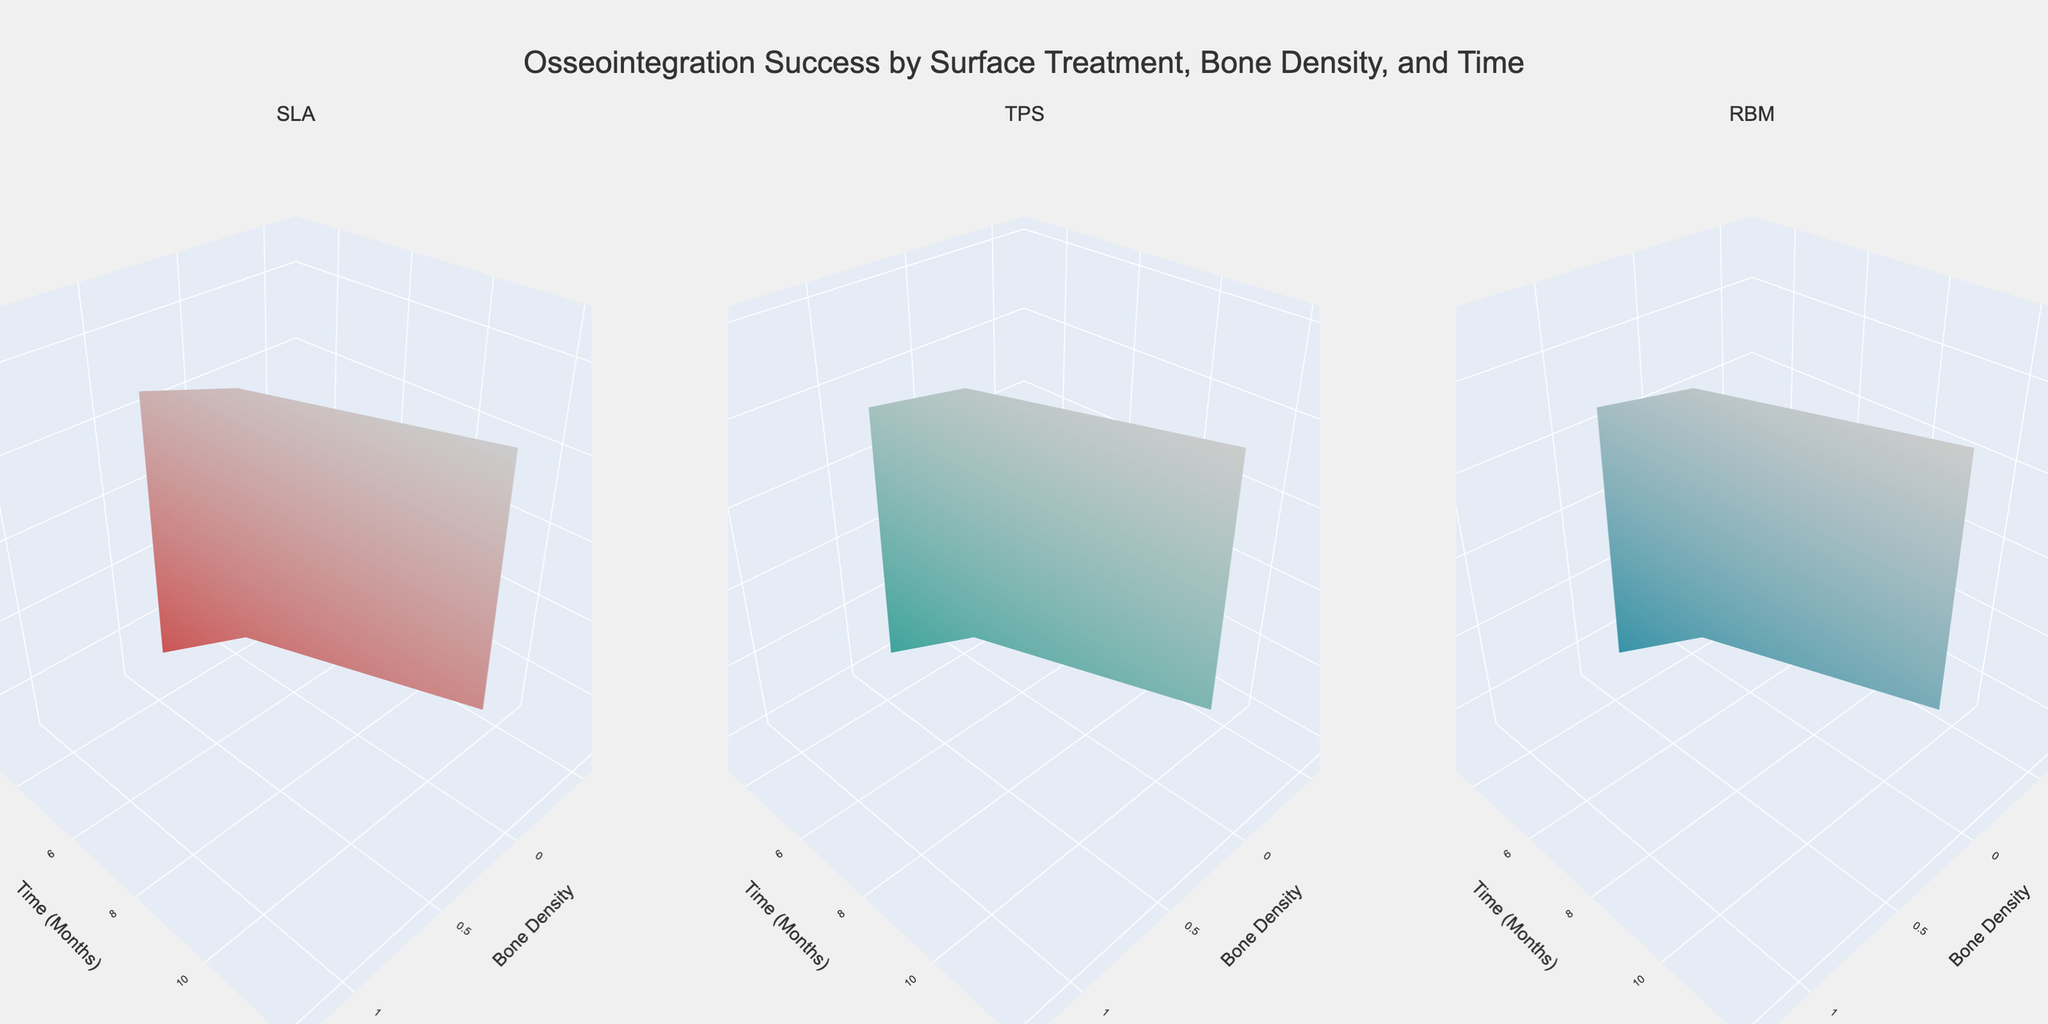What's the title of the plot? The title is centrally positioned at the top of the figure. It reads, "Osseointegration Success by Surface Treatment, Bone Density, and Time".
Answer: Osseointegration Success by Surface Treatment, Bone Density, and Time What are the three surface treatments compared in the subplots? The subplot titles along the top indicate the three surface treatments being compared: "SLA", "TPS", and "RBM".
Answer: SLA, TPS, RBM How does the osseointegration success rate change over time for SLA surface treatment with a bone density of 0.6? For SLA and bone density 0.6, the osseointegration success rates at time points 3, 6, and 12 months are shown as surfaces. At 3 months, it’s 78%, at 6 months, it's 89%, and at 12 months, it's 94%.
Answer: 78% at 3 months, 89% at 6 months, 94% at 12 months Which surface treatment shows the highest osseointegration success after 12 months for bone density of 0.9? By comparing the three subplots, all treatments reach their highest points at 12 months for bone density of 0.9. Among these, SLA has the highest value at 97%.
Answer: SLA What is the difference in osseointegration success at 6 months between bone densities 0.3 and 0.9 for TPS surface treatment? For TPS at 6 months, the osseointegration success rates for bone densities 0.3 and 0.9 can be observed. For bone density 0.3, it's 82%, and for 0.9, it’s 90%. The difference is 90% - 82% = 8%.
Answer: 8% Out of the three surface treatments, which one shows the lowest osseointegration success at the earliest time point for bone density of 0.3? At the 3-month mark for bone density 0.3, SLA is 72%, TPS is 70%, and RBM is 68%. RBM has the lowest value.
Answer: RBM If a patient has a bone density of 0.6, which surface treatment shows the maximum improvement in osseointegration success from 3 to 12 months? Calculate the differences in osseointegration success from 3 to 12 months for bone density 0.6 across all treatments. SLA improves by (94%-78%)=16%, TPS by (92%-76%)=16%, and RBM by (90%-74%)=16%. Hence, all treatments show the same maximum improvement of 16%.
Answer: SLA, TPS, RBM What can you infer about the effectiveness of SLA surface treatment over time compared to TPS and RBM, given different bone densities? By analyzing the surfaces, SLA shows consistently higher success rates over time across different bone densities compared to TPS and RBM, reaching the highest overall success at 12 months for each bone density.
Answer: SLA is more effective overall 